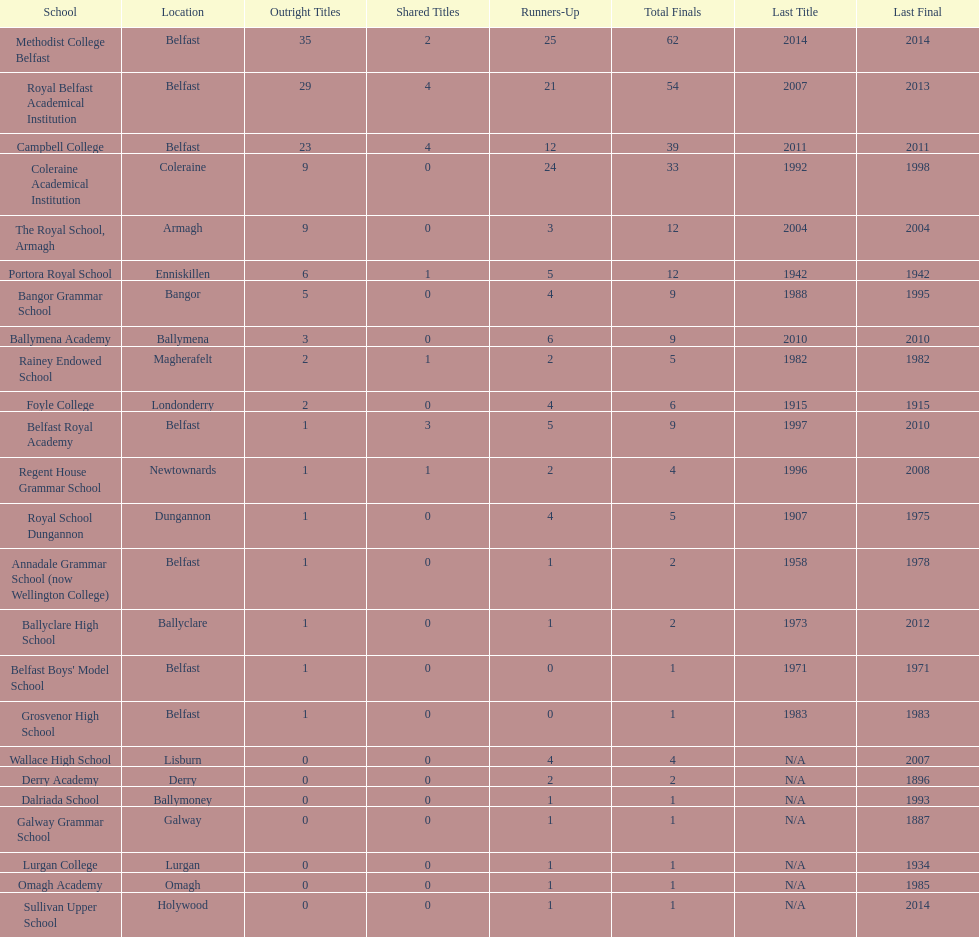In which schools can the greatest amount of common titles be found? Royal Belfast Academical Institution, Campbell College. 